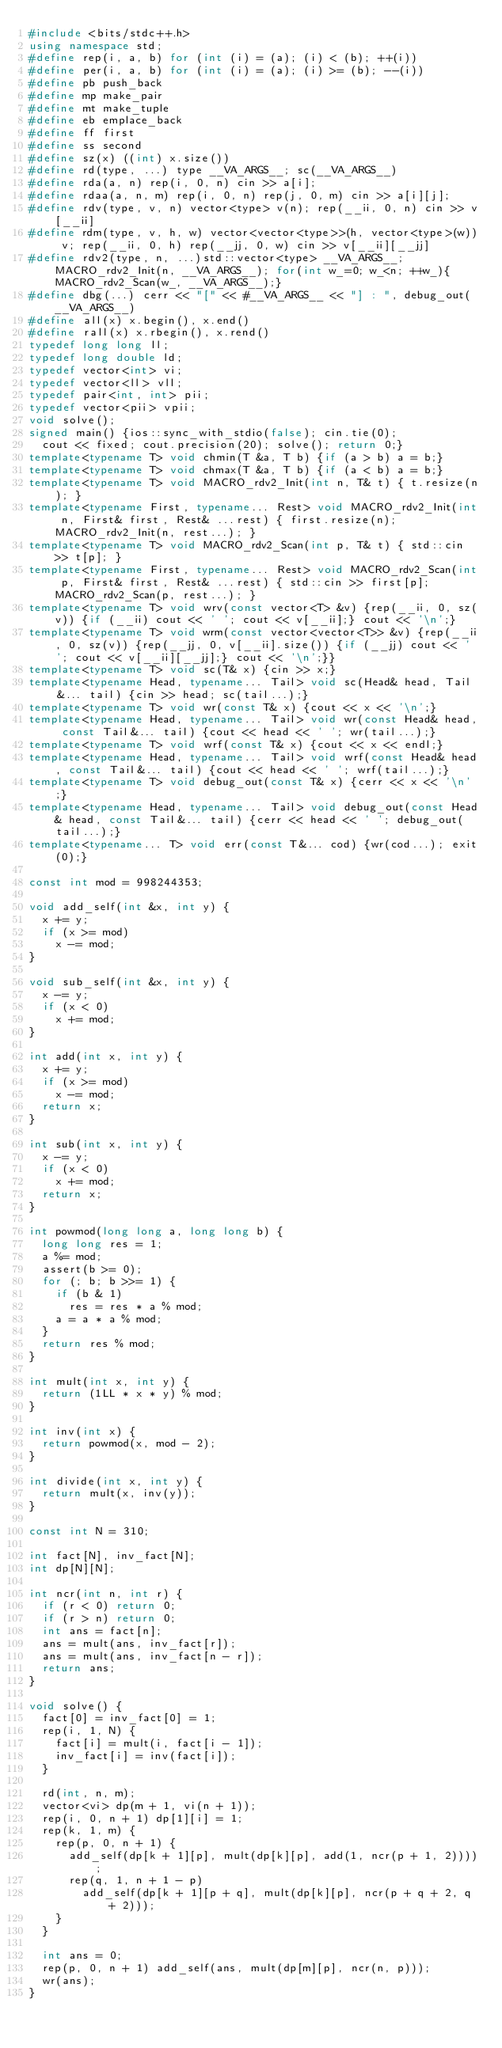<code> <loc_0><loc_0><loc_500><loc_500><_C++_>#include <bits/stdc++.h>
using namespace std;
#define rep(i, a, b) for (int (i) = (a); (i) < (b); ++(i))
#define per(i, a, b) for (int (i) = (a); (i) >= (b); --(i))
#define pb push_back
#define mp make_pair
#define mt make_tuple
#define eb emplace_back
#define ff first
#define ss second
#define sz(x) ((int) x.size())
#define rd(type, ...) type __VA_ARGS__; sc(__VA_ARGS__)
#define rda(a, n) rep(i, 0, n) cin >> a[i];
#define rdaa(a, n, m) rep(i, 0, n) rep(j, 0, m) cin >> a[i][j];
#define rdv(type, v, n) vector<type> v(n); rep(__ii, 0, n) cin >> v[__ii]
#define rdm(type, v, h, w) vector<vector<type>>(h, vector<type>(w)) v; rep(__ii, 0, h) rep(__jj, 0, w) cin >> v[__ii][__jj]
#define rdv2(type, n, ...)std::vector<type> __VA_ARGS__;MACRO_rdv2_Init(n, __VA_ARGS__); for(int w_=0; w_<n; ++w_){MACRO_rdv2_Scan(w_, __VA_ARGS__);}
#define dbg(...) cerr << "[" << #__VA_ARGS__ << "] : ", debug_out(__VA_ARGS__)
#define all(x) x.begin(), x.end()
#define rall(x) x.rbegin(), x.rend()
typedef long long ll;
typedef long double ld;
typedef vector<int> vi;
typedef vector<ll> vll;
typedef pair<int, int> pii;
typedef vector<pii> vpii;
void solve();
signed main() {ios::sync_with_stdio(false); cin.tie(0);
  cout << fixed; cout.precision(20); solve(); return 0;}
template<typename T> void chmin(T &a, T b) {if (a > b) a = b;}
template<typename T> void chmax(T &a, T b) {if (a < b) a = b;}
template<typename T> void MACRO_rdv2_Init(int n, T& t) { t.resize(n); }
template<typename First, typename... Rest> void MACRO_rdv2_Init(int n, First& first, Rest& ...rest) { first.resize(n); MACRO_rdv2_Init(n, rest...); }
template<typename T> void MACRO_rdv2_Scan(int p, T& t) { std::cin >> t[p]; }
template<typename First, typename... Rest> void MACRO_rdv2_Scan(int p, First& first, Rest& ...rest) { std::cin >> first[p]; MACRO_rdv2_Scan(p, rest...); }
template<typename T> void wrv(const vector<T> &v) {rep(__ii, 0, sz(v)) {if (__ii) cout << ' '; cout << v[__ii];} cout << '\n';} 
template<typename T> void wrm(const vector<vector<T>> &v) {rep(__ii, 0, sz(v)) {rep(__jj, 0, v[__ii].size()) {if (__jj) cout << ' '; cout << v[__ii][__jj];} cout << '\n';}}
template<typename T> void sc(T& x) {cin >> x;}
template<typename Head, typename... Tail> void sc(Head& head, Tail&... tail) {cin >> head; sc(tail...);}
template<typename T> void wr(const T& x) {cout << x << '\n';}
template<typename Head, typename... Tail> void wr(const Head& head, const Tail&... tail) {cout << head << ' '; wr(tail...);}
template<typename T> void wrf(const T& x) {cout << x << endl;}
template<typename Head, typename... Tail> void wrf(const Head& head, const Tail&... tail) {cout << head << ' '; wrf(tail...);}
template<typename T> void debug_out(const T& x) {cerr << x << '\n';}
template<typename Head, typename... Tail> void debug_out(const Head& head, const Tail&... tail) {cerr << head << ' '; debug_out(tail...);}
template<typename... T> void err(const T&... cod) {wr(cod...); exit(0);}

const int mod = 998244353;

void add_self(int &x, int y) {
  x += y;
  if (x >= mod)
    x -= mod;
}

void sub_self(int &x, int y) {
  x -= y;
  if (x < 0)
    x += mod;
}

int add(int x, int y) {
  x += y;
  if (x >= mod)
    x -= mod;
  return x;
}

int sub(int x, int y) {
  x -= y;
  if (x < 0)
    x += mod;
  return x;
}

int powmod(long long a, long long b) {
  long long res = 1;
  a %= mod;
  assert(b >= 0);
  for (; b; b >>= 1) {
    if (b & 1)
      res = res * a % mod;
    a = a * a % mod;
  }
  return res % mod;
}

int mult(int x, int y) {
  return (1LL * x * y) % mod;
}

int inv(int x) {
  return powmod(x, mod - 2);
}

int divide(int x, int y) {
  return mult(x, inv(y));
}

const int N = 310;

int fact[N], inv_fact[N];
int dp[N][N];

int ncr(int n, int r) {
  if (r < 0) return 0;
  if (r > n) return 0;
  int ans = fact[n];
  ans = mult(ans, inv_fact[r]);
  ans = mult(ans, inv_fact[n - r]);
  return ans;
}

void solve() {
  fact[0] = inv_fact[0] = 1;
  rep(i, 1, N) {
    fact[i] = mult(i, fact[i - 1]);
    inv_fact[i] = inv(fact[i]);
  }

  rd(int, n, m);
  vector<vi> dp(m + 1, vi(n + 1));
  rep(i, 0, n + 1) dp[1][i] = 1;
  rep(k, 1, m) {
    rep(p, 0, n + 1) {
      add_self(dp[k + 1][p], mult(dp[k][p], add(1, ncr(p + 1, 2))));
      rep(q, 1, n + 1 - p)
        add_self(dp[k + 1][p + q], mult(dp[k][p], ncr(p + q + 2, q + 2)));
    }
  }

  int ans = 0;
  rep(p, 0, n + 1) add_self(ans, mult(dp[m][p], ncr(n, p)));
  wr(ans);
}</code> 